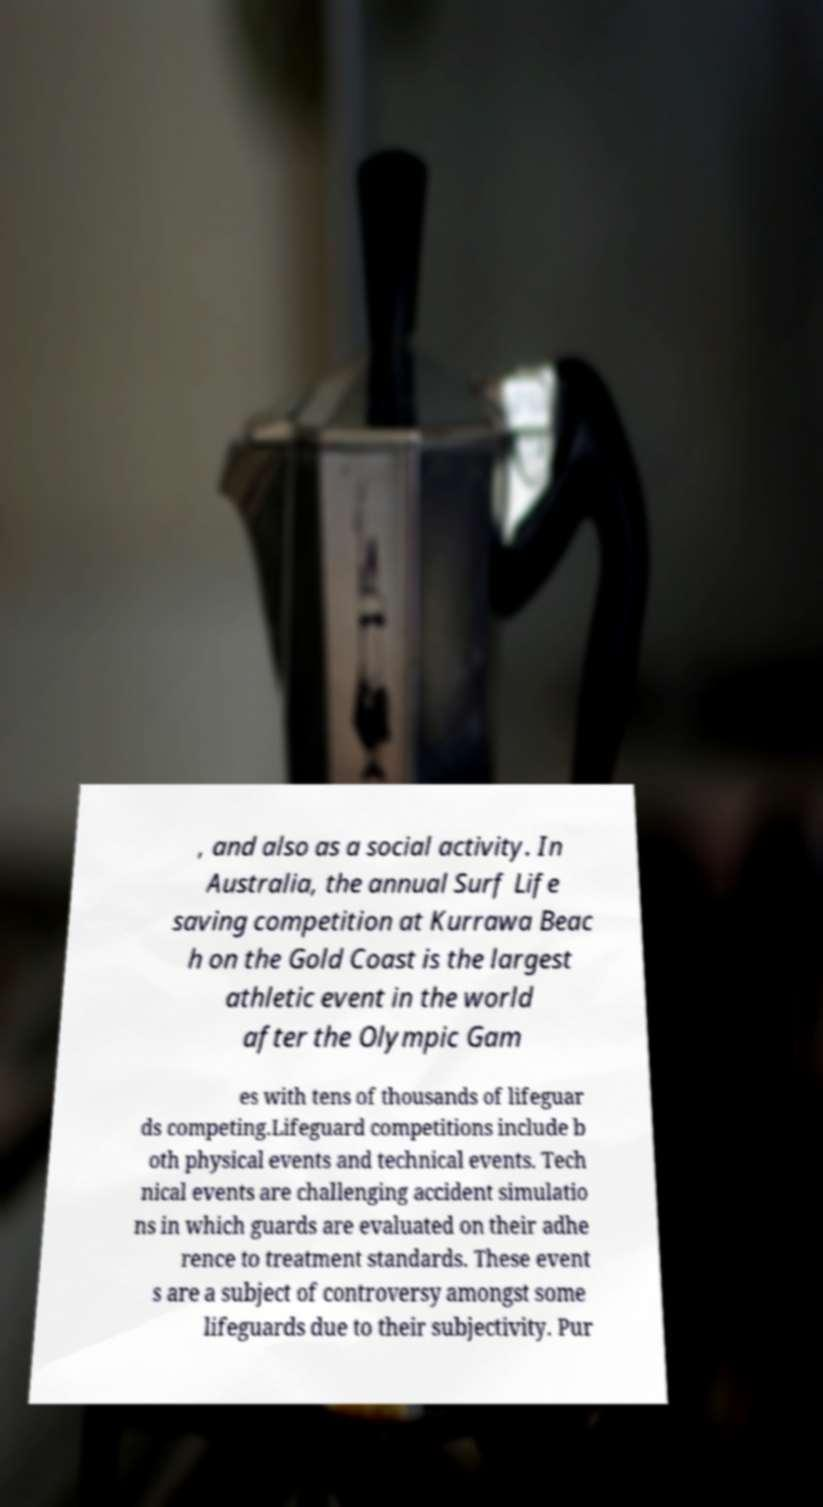Please read and relay the text visible in this image. What does it say? , and also as a social activity. In Australia, the annual Surf Life saving competition at Kurrawa Beac h on the Gold Coast is the largest athletic event in the world after the Olympic Gam es with tens of thousands of lifeguar ds competing.Lifeguard competitions include b oth physical events and technical events. Tech nical events are challenging accident simulatio ns in which guards are evaluated on their adhe rence to treatment standards. These event s are a subject of controversy amongst some lifeguards due to their subjectivity. Pur 